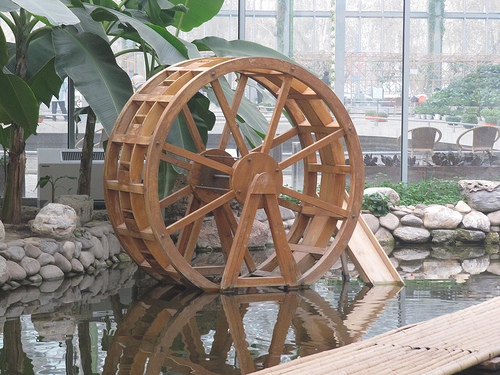<image>
Is there a glass behind the leaf? Yes. From this viewpoint, the glass is positioned behind the leaf, with the leaf partially or fully occluding the glass. Is the rock in the water? No. The rock is not contained within the water. These objects have a different spatial relationship. 